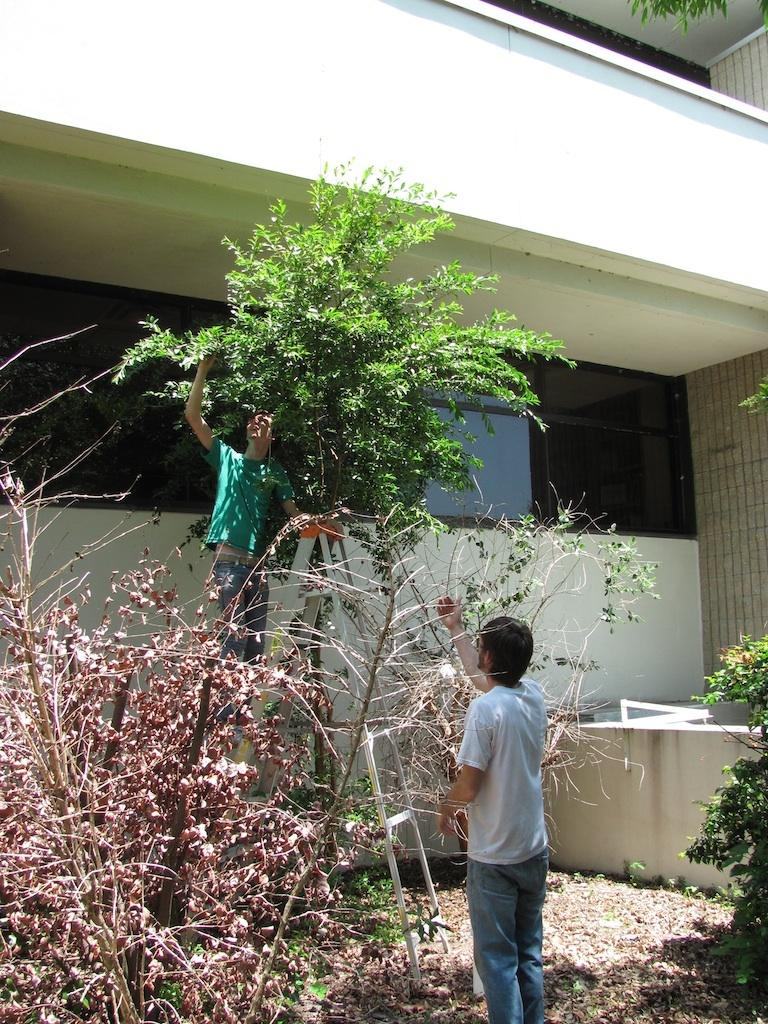How many people are present in the image? There are two persons in the image. What type of vegetation can be seen in the image? There are plants in the image. What object is used for climbing in the image? There is a ladder in the image. What type of structure is visible in the image? There is a building in the image. What can be found on the ground in the image? There are leaves on the ground in the image. What architectural feature is present in the image? There is a wall in the image. What is the cause of the zebra's stripes in the image? There is no zebra present in the image, so the cause of its stripes cannot be determined. 